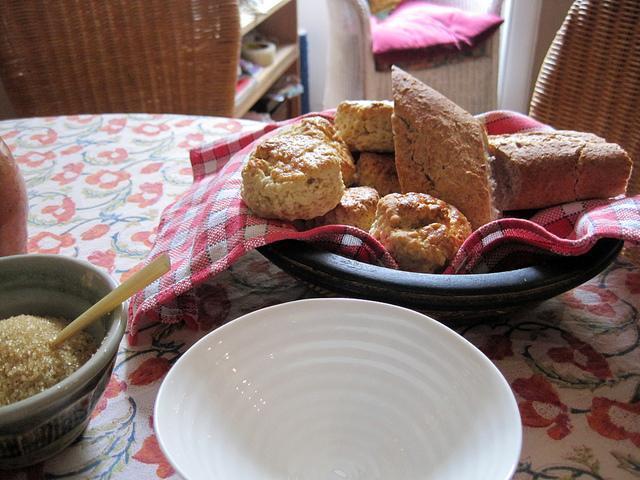How many chairs can be seen?
Give a very brief answer. 2. How many bowls are visible?
Give a very brief answer. 4. How many feet does the person have in the air?
Give a very brief answer. 0. 